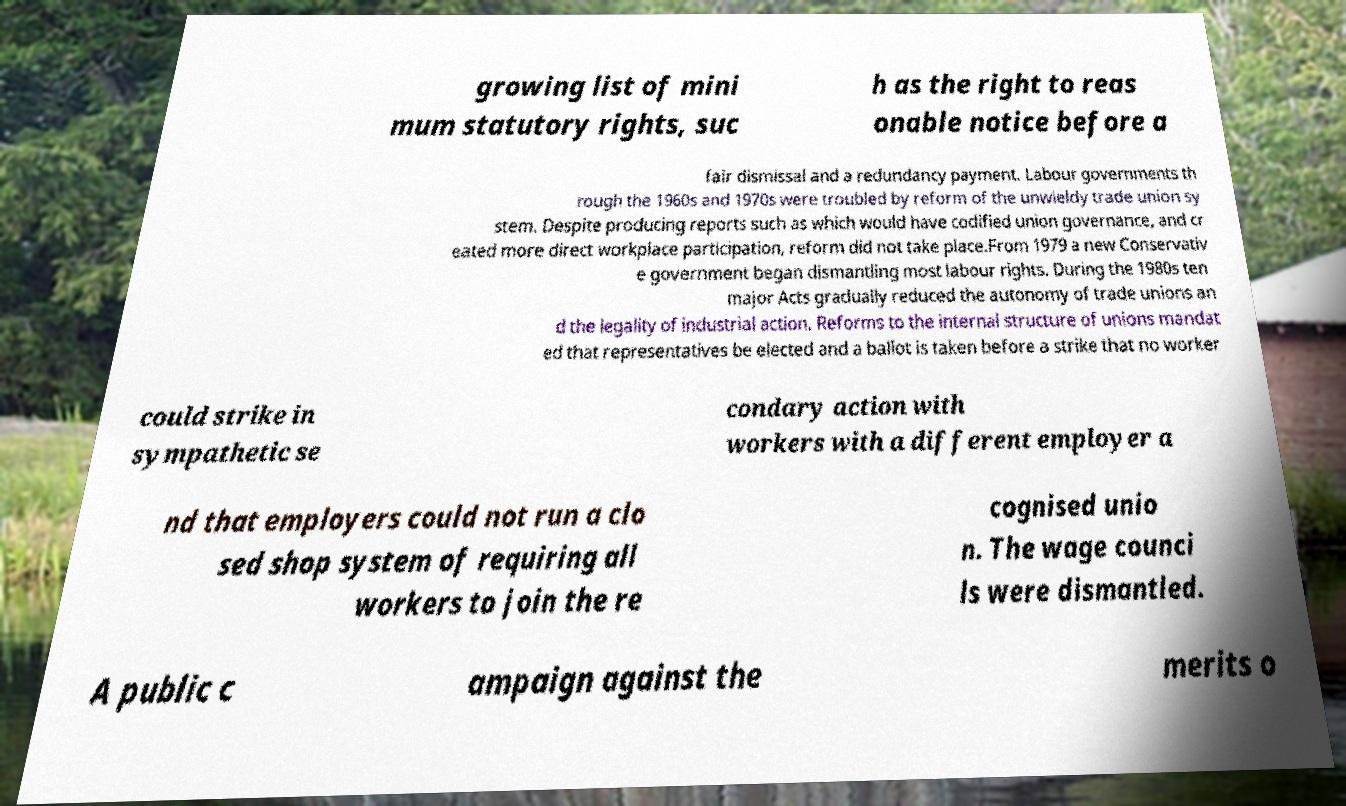For documentation purposes, I need the text within this image transcribed. Could you provide that? growing list of mini mum statutory rights, suc h as the right to reas onable notice before a fair dismissal and a redundancy payment. Labour governments th rough the 1960s and 1970s were troubled by reform of the unwieldy trade union sy stem. Despite producing reports such as which would have codified union governance, and cr eated more direct workplace participation, reform did not take place.From 1979 a new Conservativ e government began dismantling most labour rights. During the 1980s ten major Acts gradually reduced the autonomy of trade unions an d the legality of industrial action. Reforms to the internal structure of unions mandat ed that representatives be elected and a ballot is taken before a strike that no worker could strike in sympathetic se condary action with workers with a different employer a nd that employers could not run a clo sed shop system of requiring all workers to join the re cognised unio n. The wage counci ls were dismantled. A public c ampaign against the merits o 